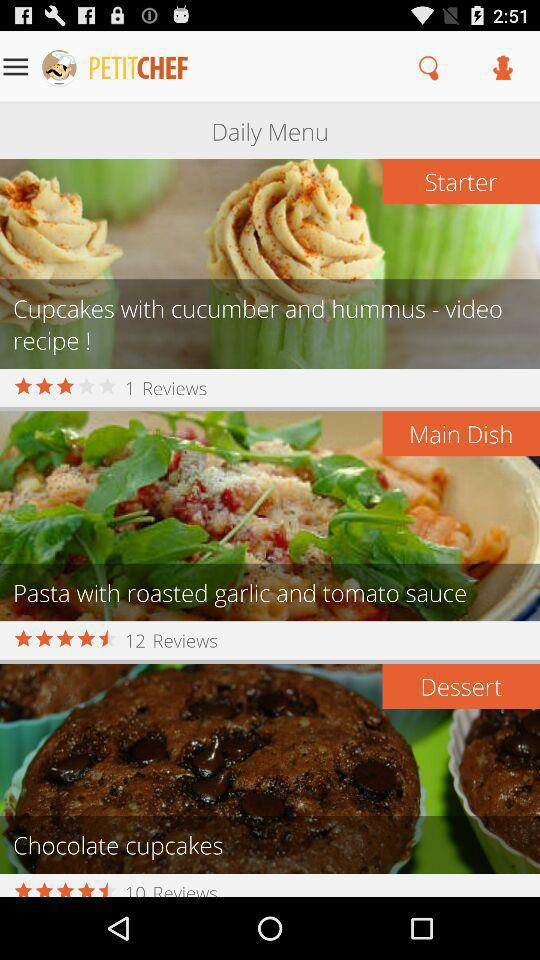What is the name of the course that has 10 reviews? The name of the course is "Dessert". 